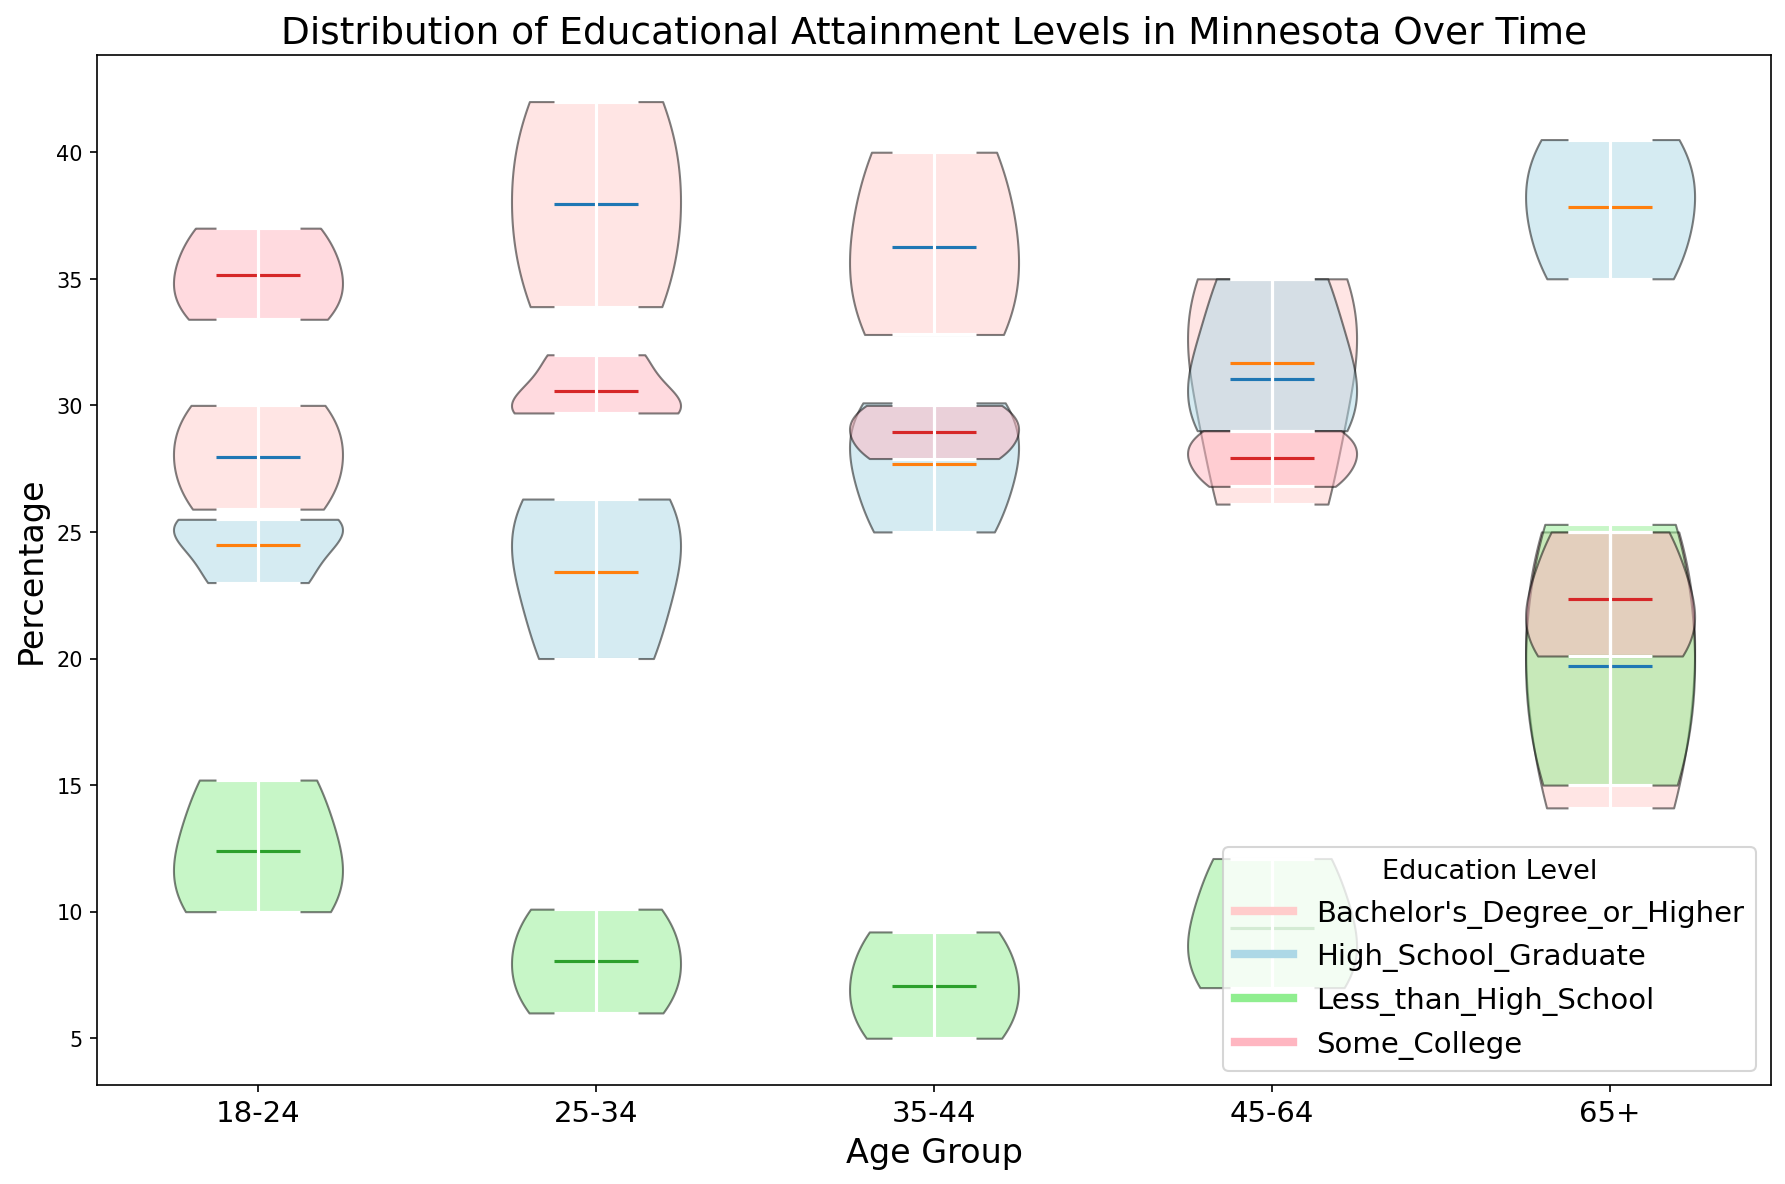What is the predominant educational level for the 18-24 age group in 2020? The widest part of the violin plot indicates the most common value. For the 18-24 age group in 2020, the widest part corresponds to "Some College".
Answer: Some College How does the percentage of "Bachelor's Degree or Higher" in the 25-34 age group compare between 2000 and 2020? By observing the means or the widths of the violins, we see that the percentage has increased. In 2000, it's around 34%, and in 2020, it's around 42%.
Answer: Increased In 2010, which age group had the highest percentage of high school graduates? Looking at the violin associated with "High School Graduate" in 2010, the widest part is for the 65+ age group.
Answer: 65+ Which age group shows the lowest percentage of "Less than High School" educational level in 2020? The violin for "Less than High School" in 2020 is narrowest for the 35-44 age group.
Answer: 35-44 What trend can you observe for the educational attainment of "Less than High School" from 2000 to 2020 across different age groups? The trend shows a general decrease in "Less than High School" percentages in all age groups over time, with younger groups showing more significant reductions.
Answer: Decreasing Compare the median educational level for the 45-64 age group between 2000 and 2020. To find the median education level, look at the violin plot widths. "High School Graduate" remains a significant portion, but there is a slight increase in "Bachelor's Degree or Higher" by 2020.
Answer: Slight increase in higher education By approximately how much did the percentage of "Some College" level change for the 18-24 age group from 2000 to 2020? The percentage changed from 33.4% in 2000 to 37% in 2020. This is an increase of 3.6%.
Answer: +3.6% In 2020, which educational level shows the most considerable difference in percentages between the 18-24 and 65+ age groups? In 2020, "Bachelor's Degree or Higher" has significant differences when comparing 30% for 18-24 to 25% for 65+.
Answer: "Bachelor's Degree or Higher" Is the percentage of people with a "Bachelor's Degree or Higher" higher for the 35-44 age group or the 25-34 age group in 2010? The violin plots show that in 2010, the percentage for 35-44 is around 36% while for 25-34 it is about 38%, indicating the latter is higher.
Answer: 25-34 Which age group consistently has the highest percentage of "High School Graduates" across all years? Across all years, the "65+" age group has the highest percentage of "High School Graduates" as indicated by the broadest portion of the violins for that education level.
Answer: 65+ 